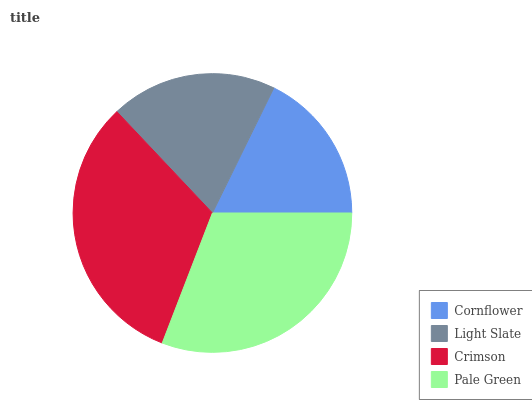Is Cornflower the minimum?
Answer yes or no. Yes. Is Crimson the maximum?
Answer yes or no. Yes. Is Light Slate the minimum?
Answer yes or no. No. Is Light Slate the maximum?
Answer yes or no. No. Is Light Slate greater than Cornflower?
Answer yes or no. Yes. Is Cornflower less than Light Slate?
Answer yes or no. Yes. Is Cornflower greater than Light Slate?
Answer yes or no. No. Is Light Slate less than Cornflower?
Answer yes or no. No. Is Pale Green the high median?
Answer yes or no. Yes. Is Light Slate the low median?
Answer yes or no. Yes. Is Crimson the high median?
Answer yes or no. No. Is Crimson the low median?
Answer yes or no. No. 